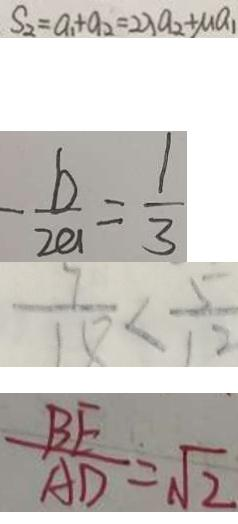Convert formula to latex. <formula><loc_0><loc_0><loc_500><loc_500>S _ { 2 } = a _ { 1 } + a _ { 2 } = 2 \lambda a _ { 2 } + M a _ { 1 } 
 - \frac { b } { 2 a } = \frac { 1 } { 3 } 
 \frac { 7 } { 1 8 } < \frac { 5 } { 1 2 } 
 \frac { B E } { A D } = \sqrt { 2 }</formula> 